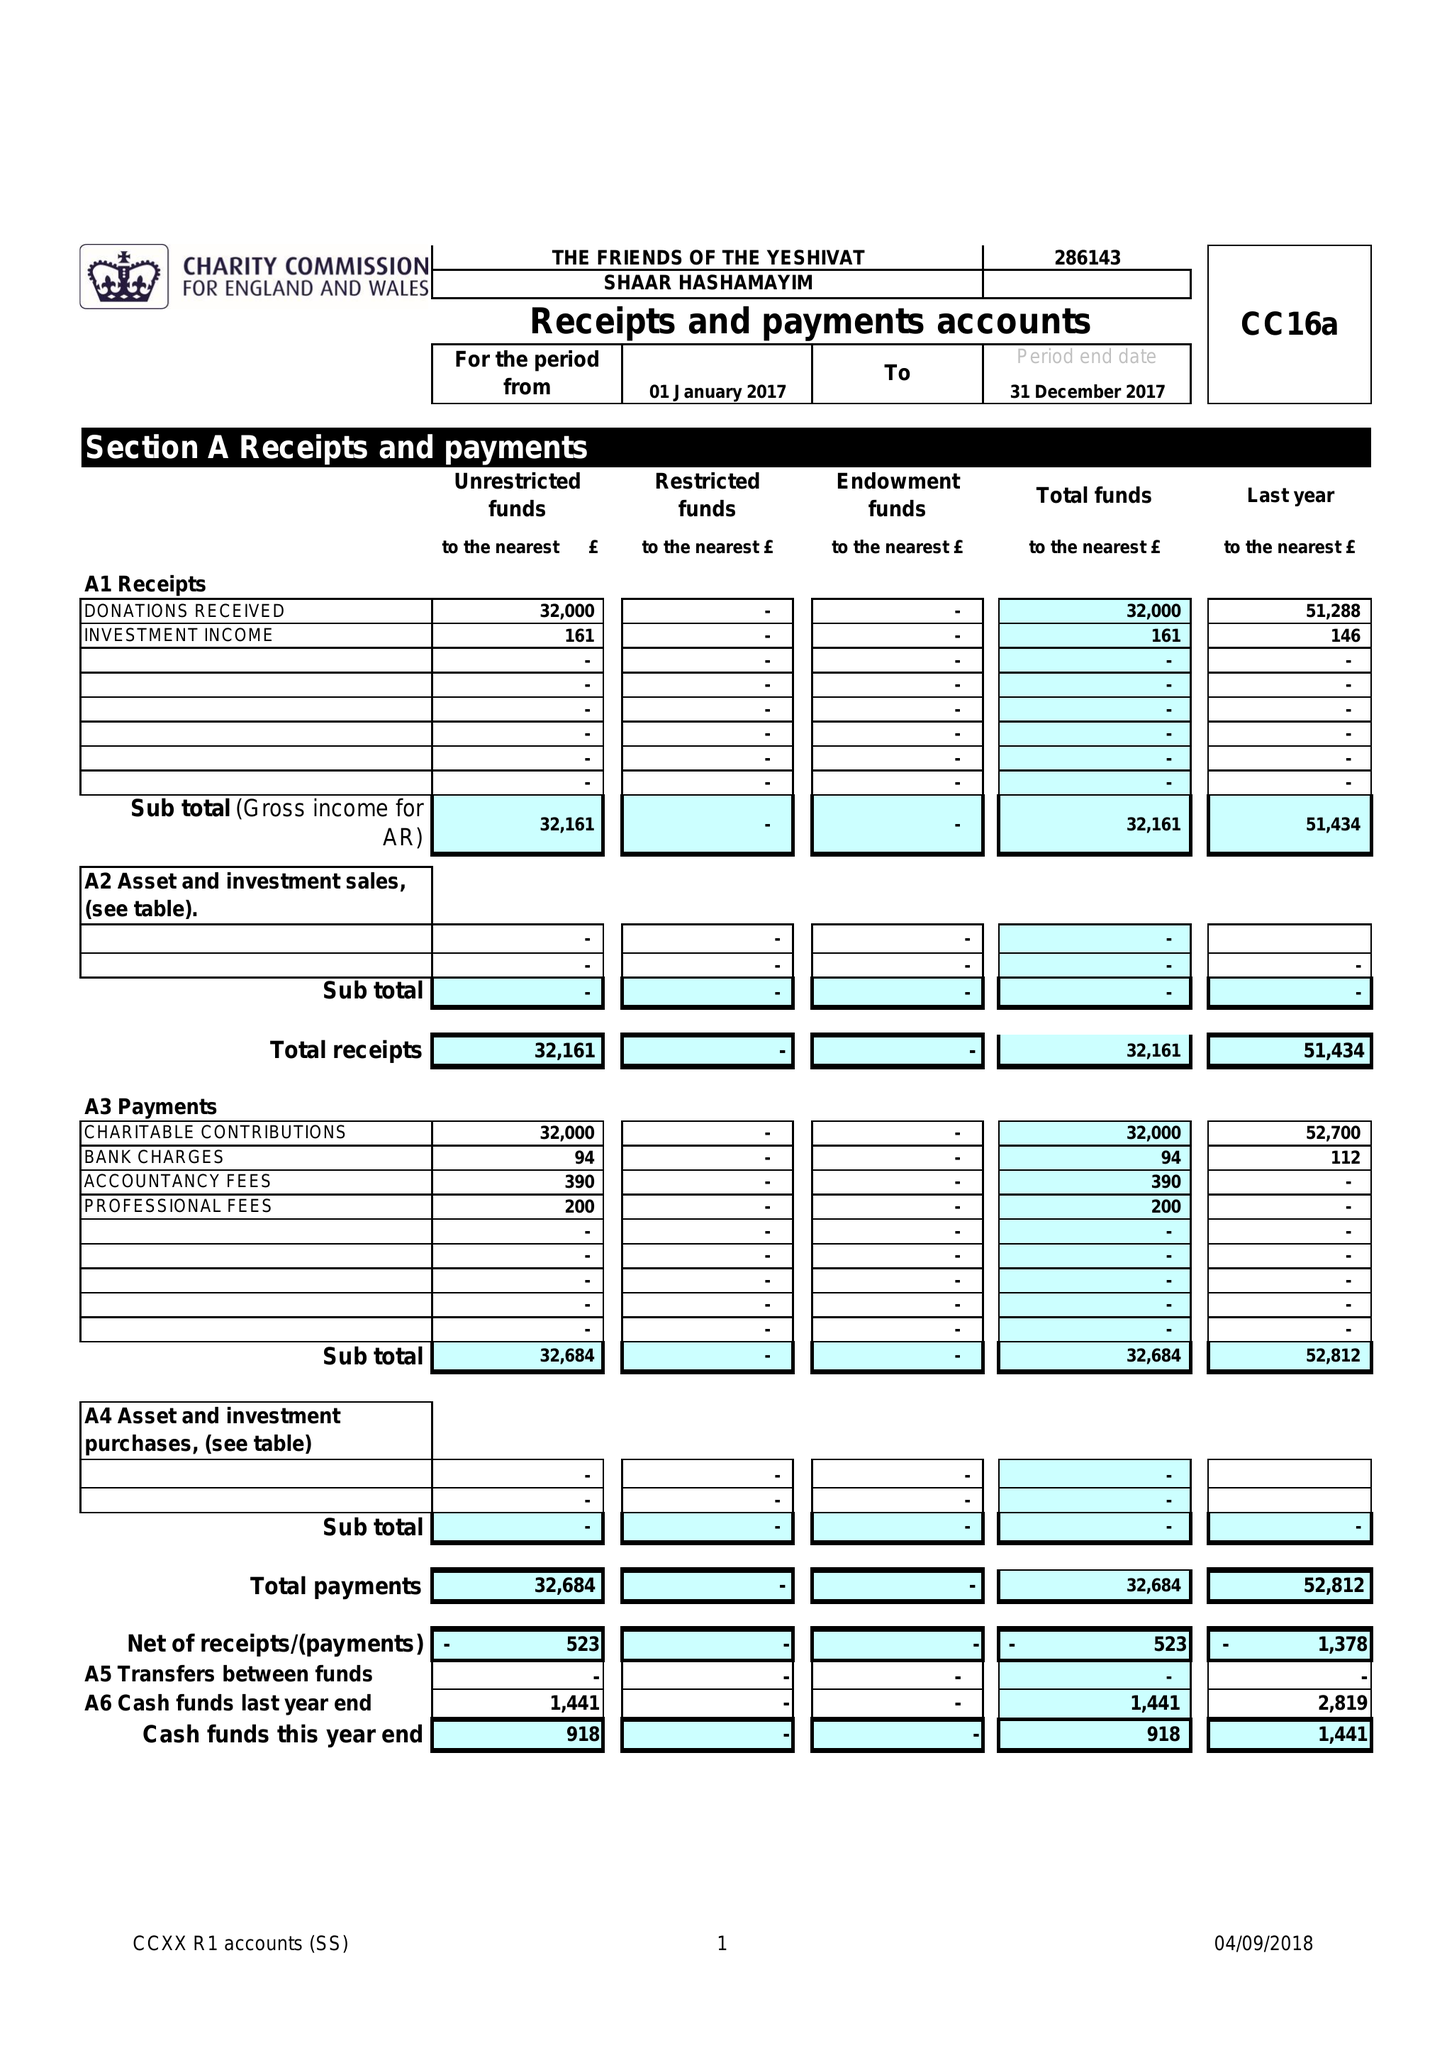What is the value for the charity_name?
Answer the question using a single word or phrase. The Friends Of The Yeshivat Shaar Hashamayim 